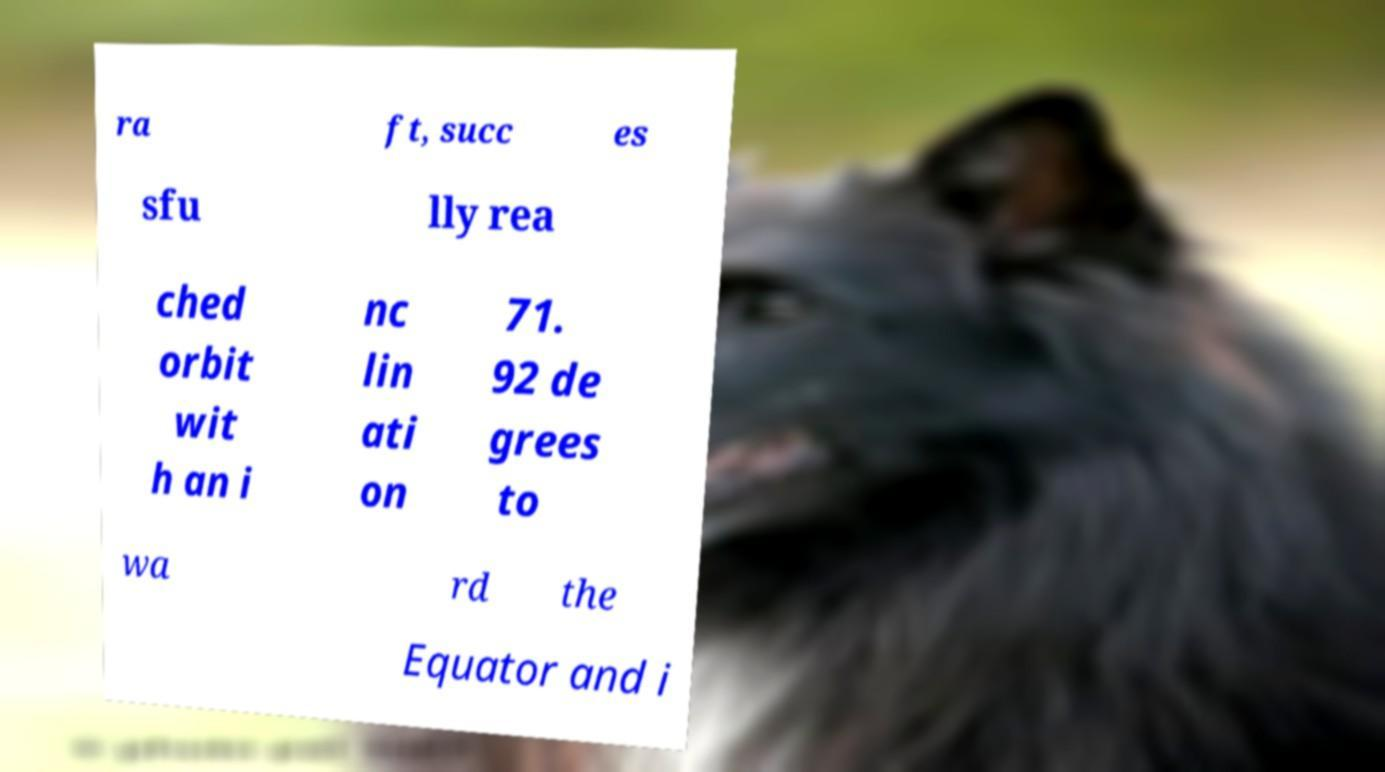Can you accurately transcribe the text from the provided image for me? ra ft, succ es sfu lly rea ched orbit wit h an i nc lin ati on 71. 92 de grees to wa rd the Equator and i 